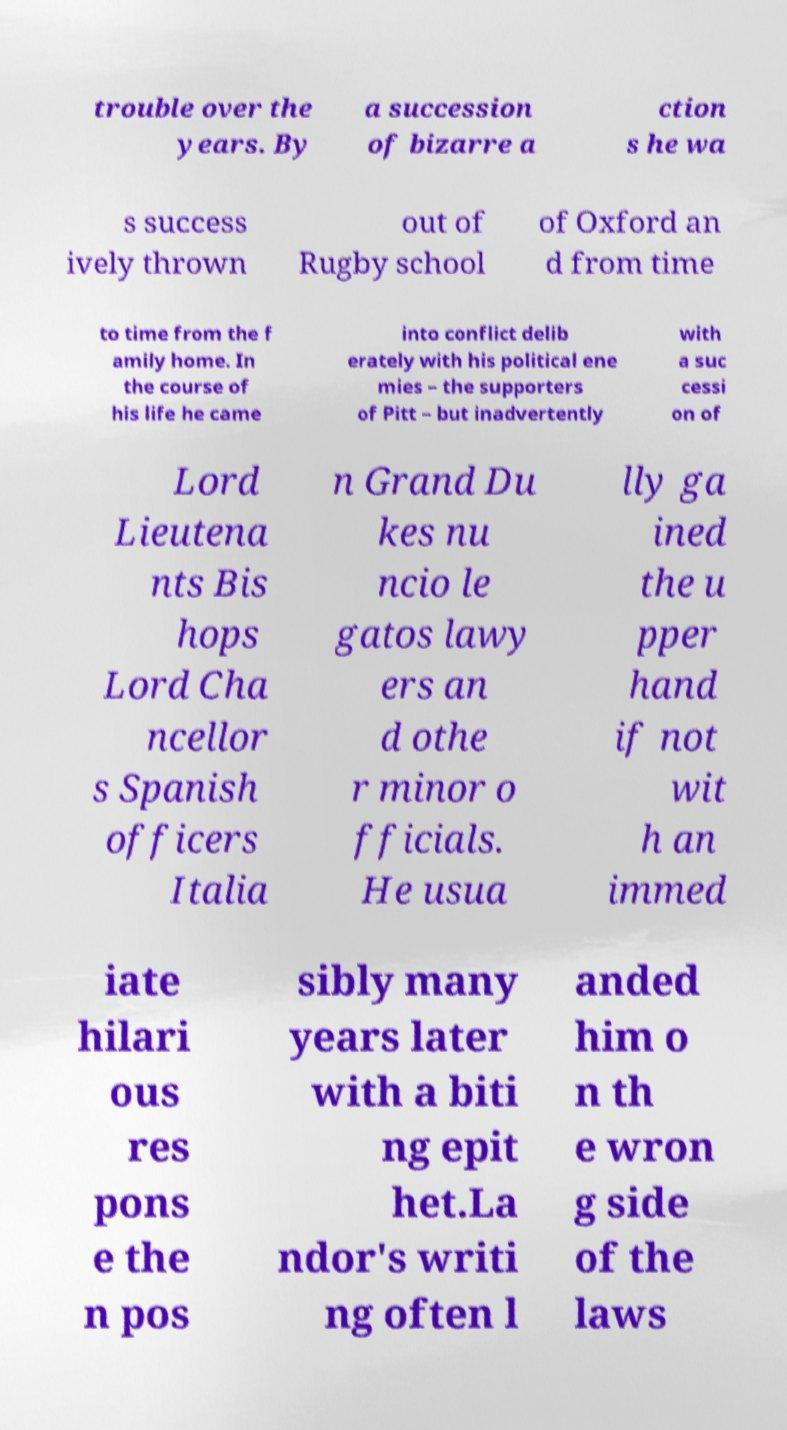Can you accurately transcribe the text from the provided image for me? trouble over the years. By a succession of bizarre a ction s he wa s success ively thrown out of Rugby school of Oxford an d from time to time from the f amily home. In the course of his life he came into conflict delib erately with his political ene mies – the supporters of Pitt – but inadvertently with a suc cessi on of Lord Lieutena nts Bis hops Lord Cha ncellor s Spanish officers Italia n Grand Du kes nu ncio le gatos lawy ers an d othe r minor o fficials. He usua lly ga ined the u pper hand if not wit h an immed iate hilari ous res pons e the n pos sibly many years later with a biti ng epit het.La ndor's writi ng often l anded him o n th e wron g side of the laws 